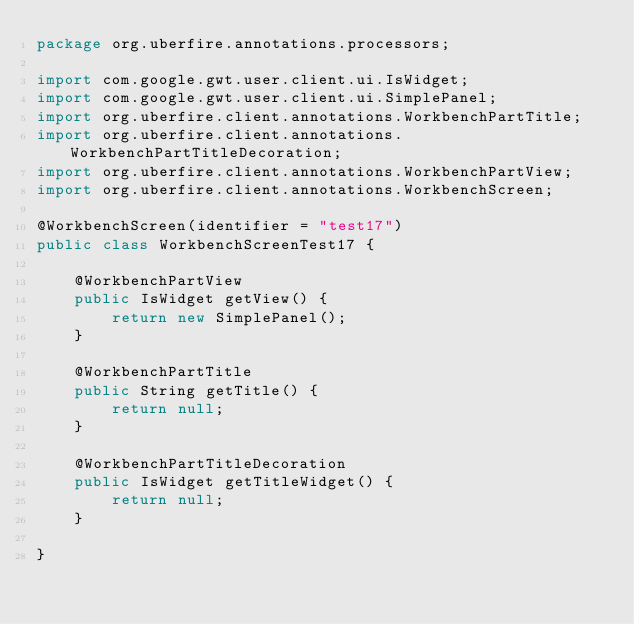<code> <loc_0><loc_0><loc_500><loc_500><_Java_>package org.uberfire.annotations.processors;

import com.google.gwt.user.client.ui.IsWidget;
import com.google.gwt.user.client.ui.SimplePanel;
import org.uberfire.client.annotations.WorkbenchPartTitle;
import org.uberfire.client.annotations.WorkbenchPartTitleDecoration;
import org.uberfire.client.annotations.WorkbenchPartView;
import org.uberfire.client.annotations.WorkbenchScreen;

@WorkbenchScreen(identifier = "test17")
public class WorkbenchScreenTest17 {

    @WorkbenchPartView
    public IsWidget getView() {
        return new SimplePanel();
    }

    @WorkbenchPartTitle
    public String getTitle() {
        return null;
    }

    @WorkbenchPartTitleDecoration
    public IsWidget getTitleWidget() {
        return null;
    }

}
</code> 